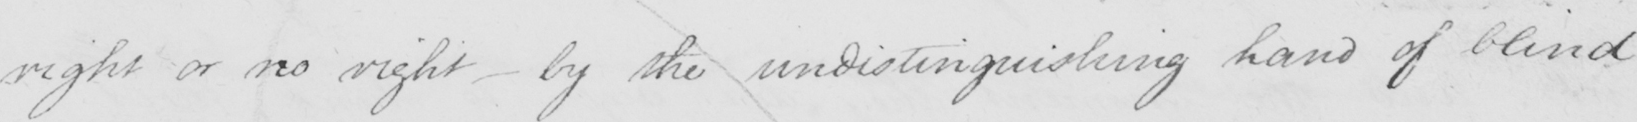Can you read and transcribe this handwriting? right or no right  _  by the undistinguishing hand of blind 